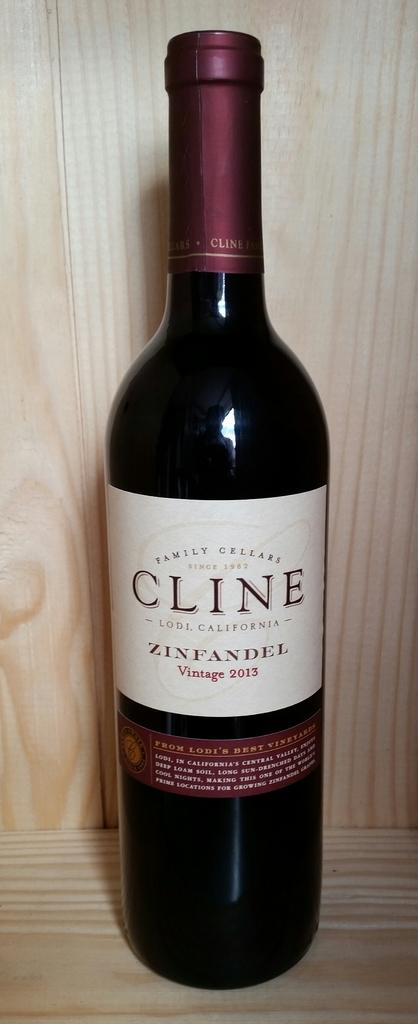<image>
Create a compact narrative representing the image presented. A bottle of 2013 Cline Zinfandel from California 